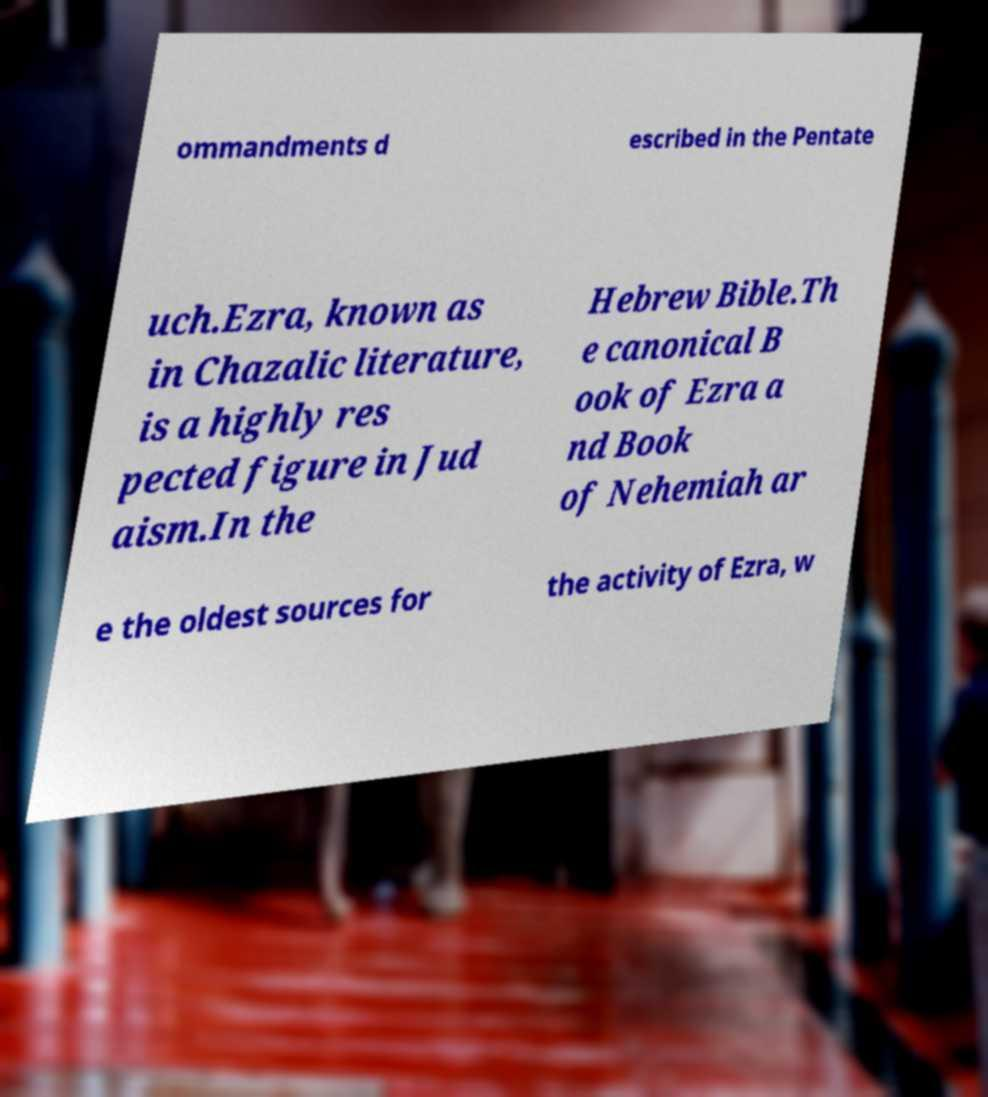Please read and relay the text visible in this image. What does it say? ommandments d escribed in the Pentate uch.Ezra, known as in Chazalic literature, is a highly res pected figure in Jud aism.In the Hebrew Bible.Th e canonical B ook of Ezra a nd Book of Nehemiah ar e the oldest sources for the activity of Ezra, w 